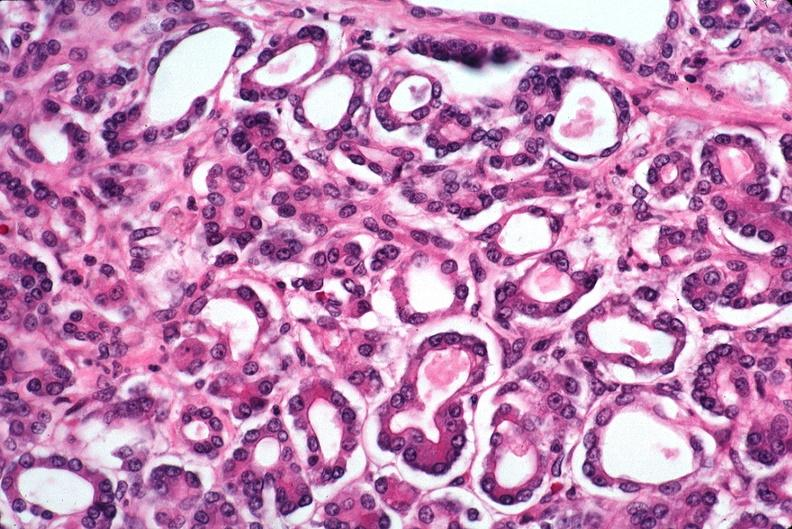does this image show pancreas, uremic pancreatitis due to polycystic kidney?
Answer the question using a single word or phrase. Yes 